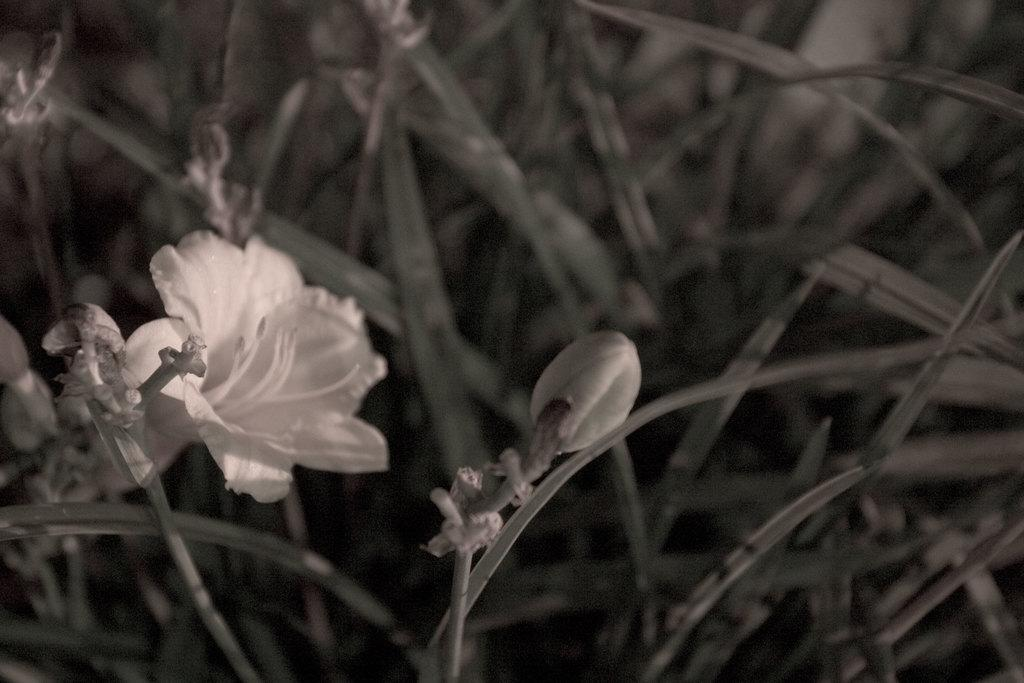What type of living organisms can be seen in the image? Plants can be seen in the image. What specific features can be observed on the plants? The plants have flowers and buds. Where is the toad sitting in the image? There is no toad present in the image. What is the bucket used for in the image? There is no bucket present in the image. 